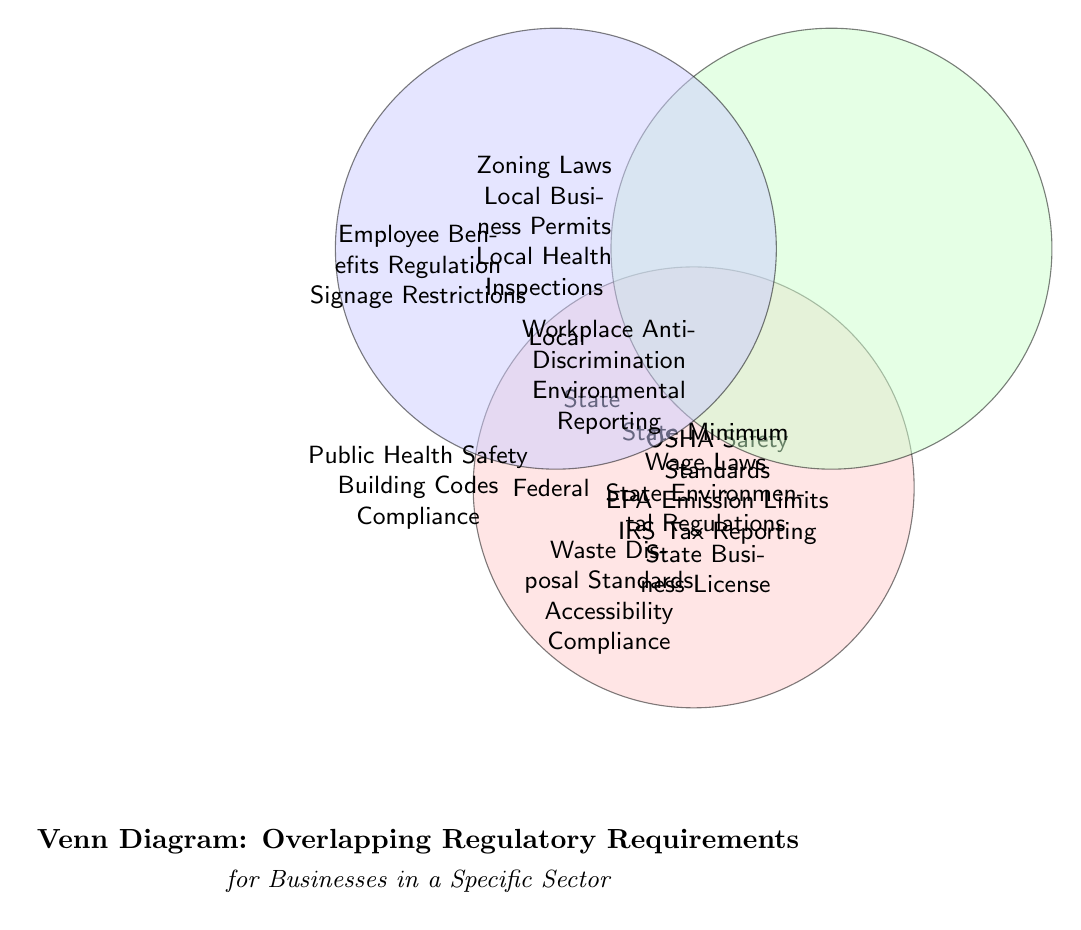What are the overlapping regulatory requirements between Federal and State authorities? The diagram shows that the overlapping requirements between Federal and State authorities include "Workplace Anti-Discrimination" and "Environmental Reporting." These are located in the intersection of the Federal and State circles.
Answer: Workplace Anti-Discrimination, Environmental Reporting How many regulatory requirements are listed under the Federal authority? The diagram explicitly lists three regulatory requirements under the Federal authority: "OSHA Safety Standards," "EPA Emission Limits," and "IRS Tax Reporting." Each is presented within the Federal circle.
Answer: 3 Which regulatory requirement is common among all three authorities? The diagram indicates that "Public Health Safety" and "Building Codes Compliance" are the regulatory requirements common to Federal, State, and Local authorities. This is represented at the center of the diagram where all three circles intersect.
Answer: Public Health Safety, Building Codes Compliance What color represents the State authority in the Venn diagram? Upon examination of the diagram, the State authority is represented by a green color, identified as "statecolor." This shading is used in the circle dedicated to the State authority.
Answer: Green How many specific requirements are listed for Local authorities? The diagram shows three specific requirements listed under Local authorities: "Zoning Laws," "Local Business Permits," and "Local Health Inspections." They are displayed within the Local circle.
Answer: 3 Which regulatory requirement is found only in the Local authority? The only regulatory requirement that is found solely within the Local authority is "Local Business Permits." This requirement is in the Local circle with no overlap with Federal or State circles.
Answer: Local Business Permits What is the total number of unique regulatory requirements shown in the diagram? To find the total number of unique regulatory requirements, count individual entries from each authority and subtract any overlaps. The diagram specifies 12 total unique entries across all circles without duplicate listing.
Answer: 12 What two requirements are only shared between Federal and Local authorities? The two requirements that are shared exclusively between Federal and Local authorities as shown in the overlapping area are "Waste Disposal Standards" and "Accessibility Compliance." They can be found in the intersection of both circles.
Answer: Waste Disposal Standards, Accessibility Compliance 